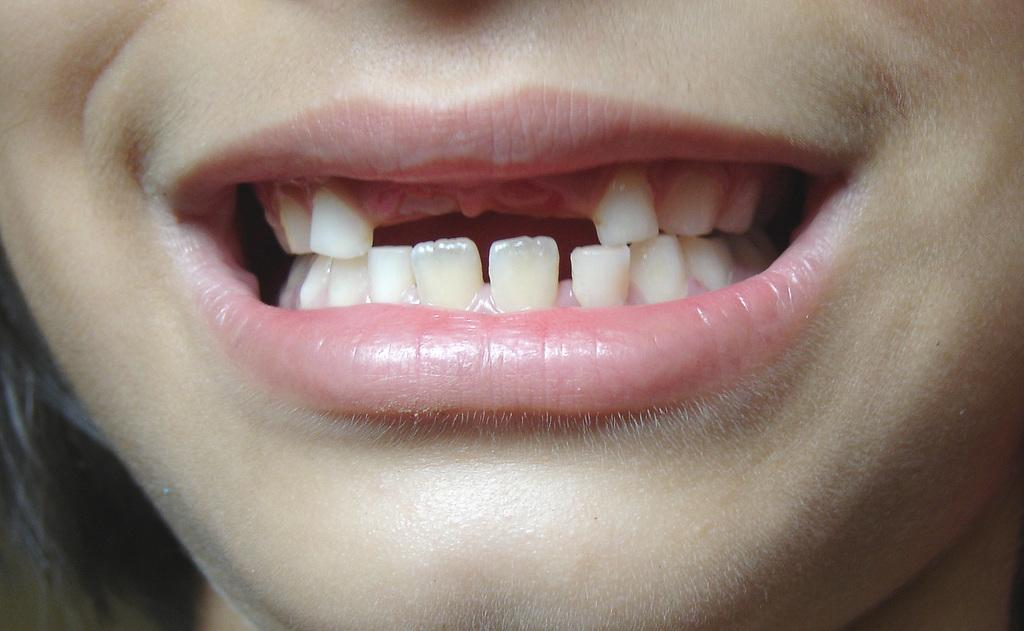What is the main subject of the image? There is a person's face in the image. What type of vacation is the person planning in the image? There is no information about a vacation or any other context in the image, as it only features a person's face. 